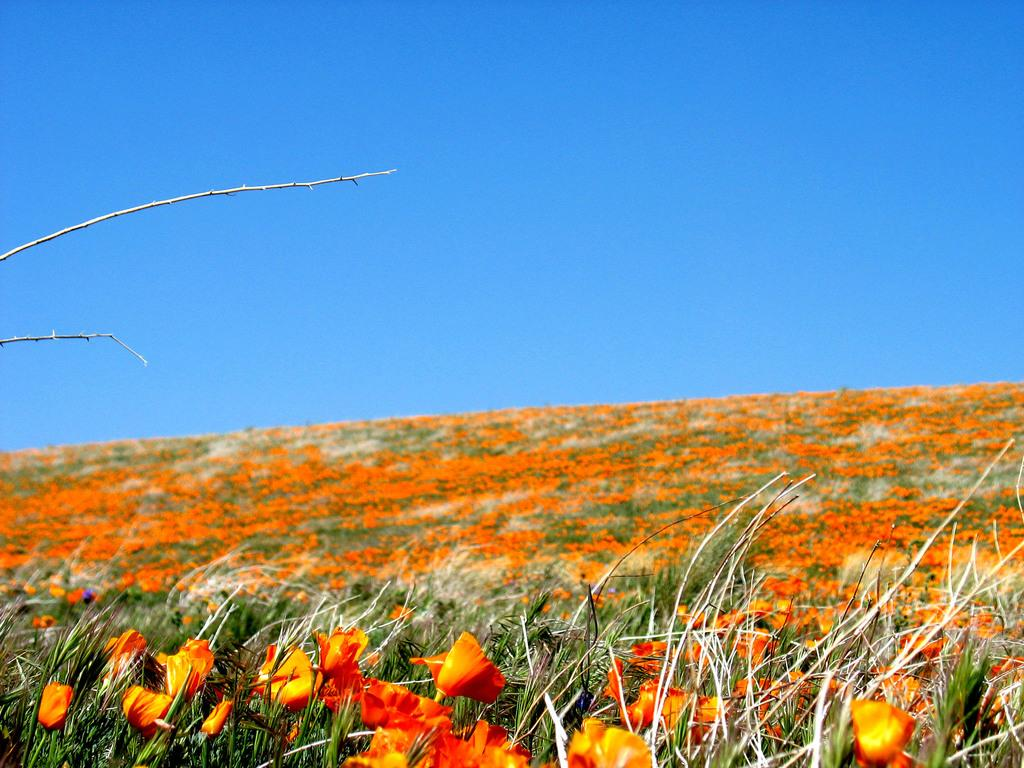What is the main setting of the image? The image appears to depict a field. What type of vegetation can be seen in the foreground? There are plants with flowers in the foreground. What is visible at the top of the image? The sky is visible at the top of the image. Can you see any walls in the image? There are no walls present in the image; it depicts a field with plants and flowers. Are there any berries visible in the image? There is no mention of berries in the provided facts, and they are not visible in the image. 